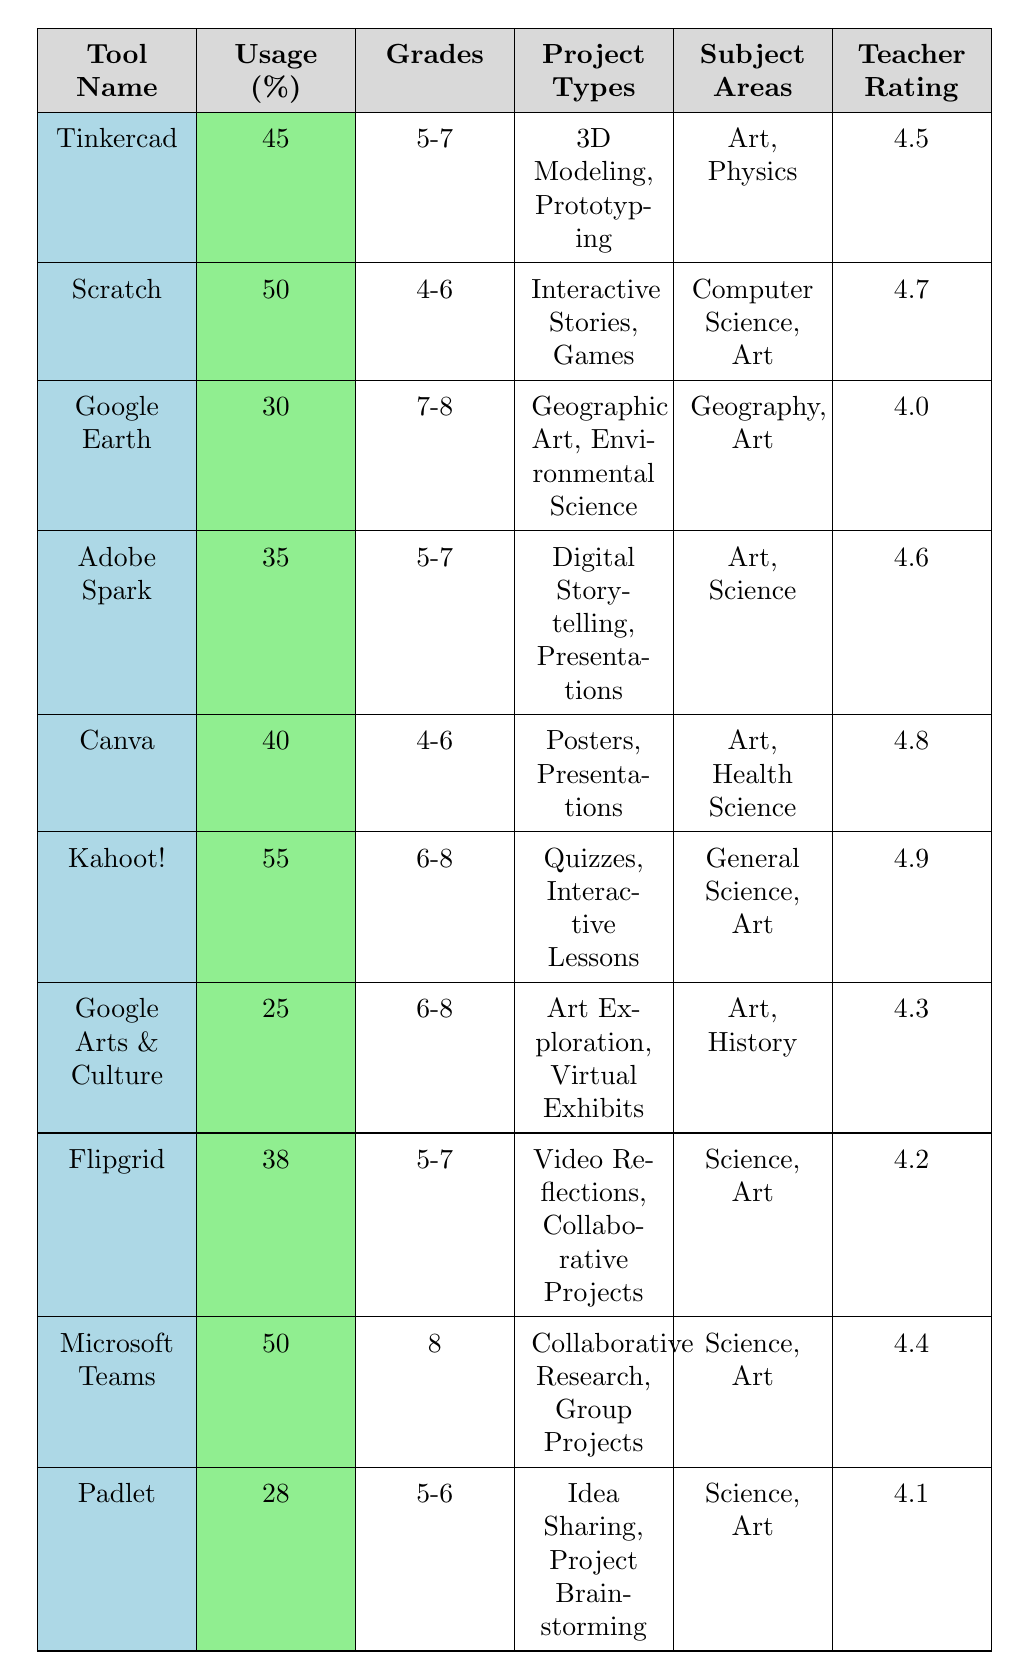What is the highest usage percentage among the digital tools listed? The table shows the usage percentages for each tool. The highest percentage is 55% for Kahoot!.
Answer: 55% Which digital tool has a teacher satisfaction rating of 4.9? By examining the ratings in the table, Kahoot! has the highest satisfaction rating at 4.9.
Answer: Kahoot! What grades are using the tool "Google Earth"? The table lists the grades for Google Earth as 7 and 8.
Answer: 7, 8 Which tool is used for 3D modeling and prototyping? Tinkercad is specifically mentioned for project types including 3D Modeling and Prototyping.
Answer: Tinkercad What percentage of users utilize "Adobe Spark" for educational projects? The usage percentage for Adobe Spark is given as 35%.
Answer: 35% Are there any tools that have an average satisfaction rating of 4.5 or higher? Checking the ratings, all tools listed have a satisfaction rating of at least 4.0; thus, yes, there are multiple tools.
Answer: Yes Which tool is primarily used for quizzes and interactive lessons? The table indicates that Kahoot! is used for quizzes and interactive lessons.
Answer: Kahoot! What is the average teacher satisfaction rating of all the tools listed? To find the average, sum the ratings: (4.5 + 4.7 + 4.0 + 4.6 + 4.8 + 4.9 + 4.3 + 4.2 + 4.4 + 4.1) = 46.5, and divide by 10 (the number of tools) to get 4.65.
Answer: 4.65 How many tools have a usage percentage below 30%? The table shows that Google Arts & Culture (25%) and Padlet (28%) are below 30%, totaling two tools.
Answer: 2 Is "Canva" used in the subject area of Health Science? According to the table, Canva is listed under subject areas including Art and Health Science.
Answer: Yes What is the difference in usage percentage between "Kahoot!" and "Padlet"? The usage percentage for Kahoot! is 55%, and for Padlet, it is 28%. The difference is 55 - 28 = 27%.
Answer: 27% What project types are linked to the tool "Scratch"? The table lists the project types associated with Scratch as Interactive Stories and Games.
Answer: Interactive Stories, Games Which tool is utilized in the 4th grade classroom? The tools applicable to the 4th grade include Scratch and Canva.
Answer: Scratch, Canva What are the subject areas that use "Flipgrid"? From the table, Flipgrid is used in the subject areas of Science and Art.
Answer: Science, Art Are there tools that serve both Art and Science subject areas? Yes, both Tinkercad and Adobe Spark serve the subject areas of Art and Science, as indicated in the table.
Answer: Yes 